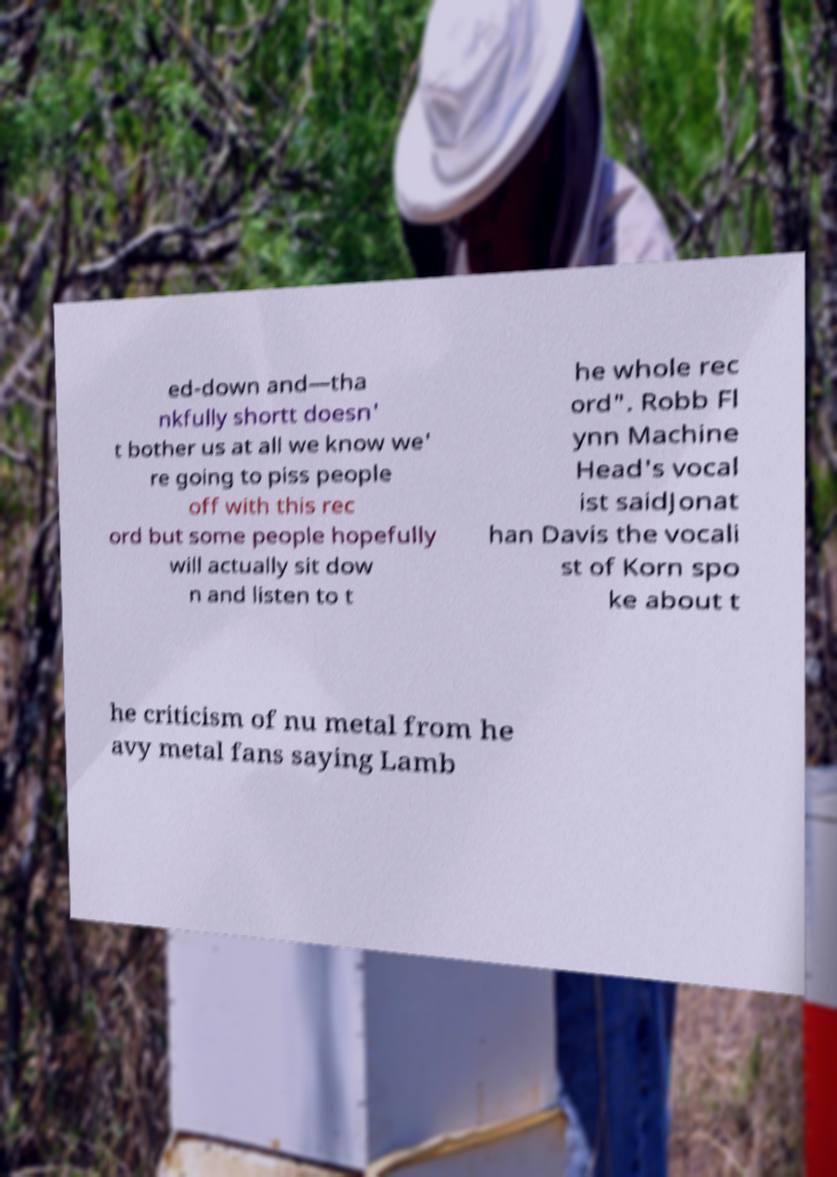Could you extract and type out the text from this image? ed-down and—tha nkfully shortt doesn' t bother us at all we know we' re going to piss people off with this rec ord but some people hopefully will actually sit dow n and listen to t he whole rec ord". Robb Fl ynn Machine Head's vocal ist saidJonat han Davis the vocali st of Korn spo ke about t he criticism of nu metal from he avy metal fans saying Lamb 